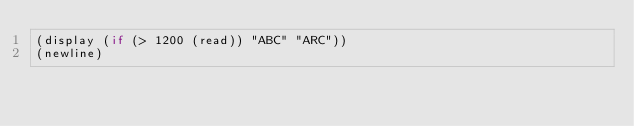<code> <loc_0><loc_0><loc_500><loc_500><_Scheme_>(display (if (> 1200 (read)) "ABC" "ARC"))
(newline)</code> 